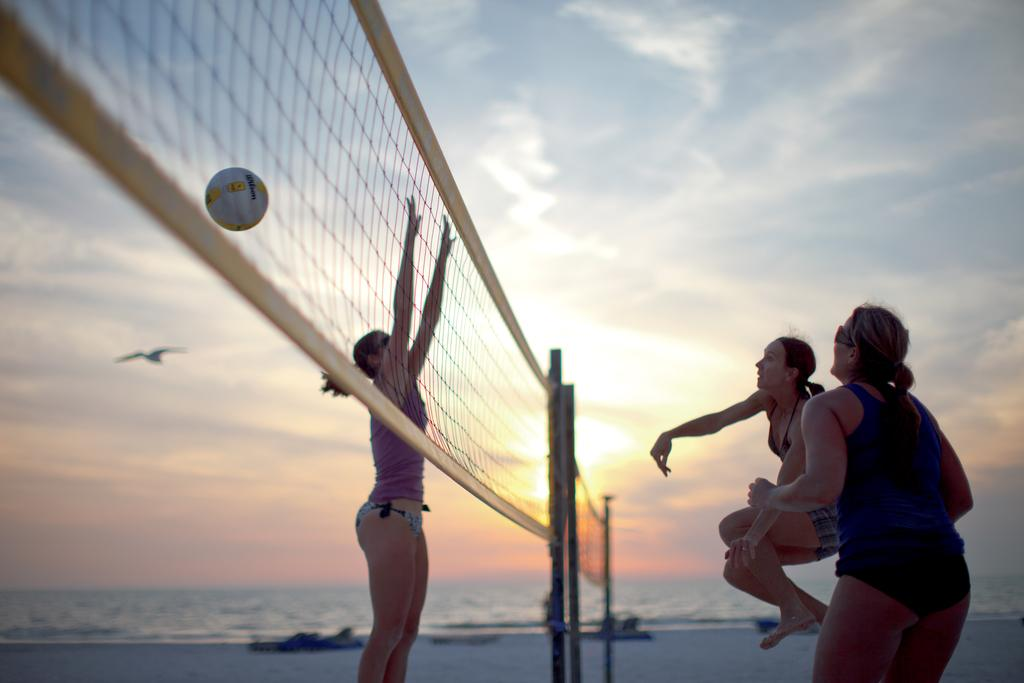How many people are playing volleyball in the image? There are three women playing volleyball in the image. Where is the volleyball game taking place? The volleyball game is taking place on the beach side. What can be seen in the background of the image? There is water visible in the background of the image. What type of weather is present in the lunchroom during the stranger's visit in the image? There is no lunchroom or stranger present in the image; it features three women playing volleyball on the beach side. 